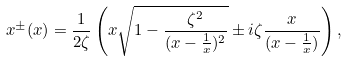Convert formula to latex. <formula><loc_0><loc_0><loc_500><loc_500>x ^ { \pm } ( x ) = \frac { 1 } { 2 \zeta } \left ( x \sqrt { 1 - \frac { \zeta ^ { 2 } } { ( x - \frac { 1 } { x } ) ^ { 2 } } } \pm i \zeta \frac { x } { ( x - \frac { 1 } { x } ) } \right ) ,</formula> 